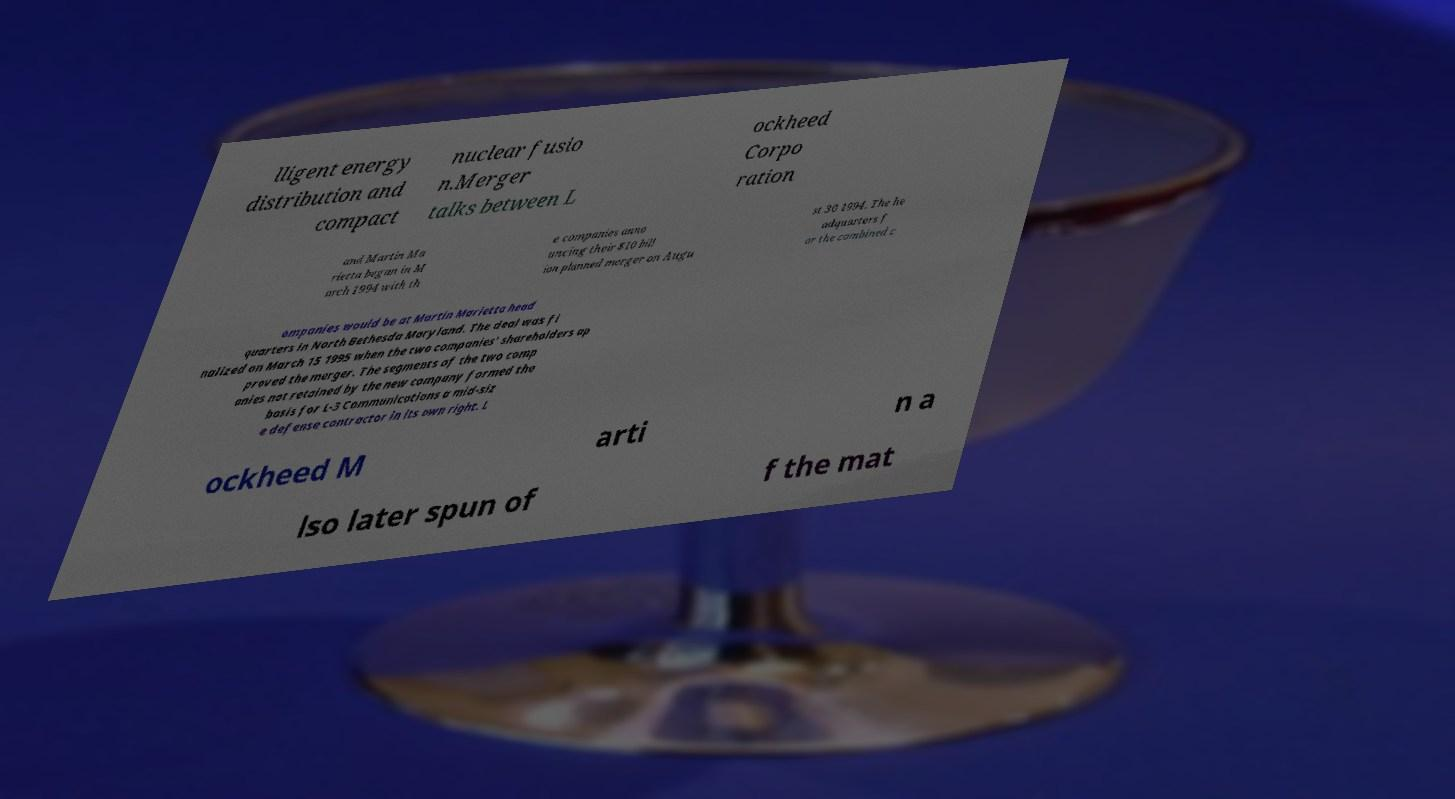Can you read and provide the text displayed in the image?This photo seems to have some interesting text. Can you extract and type it out for me? lligent energy distribution and compact nuclear fusio n.Merger talks between L ockheed Corpo ration and Martin Ma rietta began in M arch 1994 with th e companies anno uncing their $10 bill ion planned merger on Augu st 30 1994. The he adquarters f or the combined c ompanies would be at Martin Marietta head quarters in North Bethesda Maryland. The deal was fi nalized on March 15 1995 when the two companies' shareholders ap proved the merger. The segments of the two comp anies not retained by the new company formed the basis for L-3 Communications a mid-siz e defense contractor in its own right. L ockheed M arti n a lso later spun of f the mat 